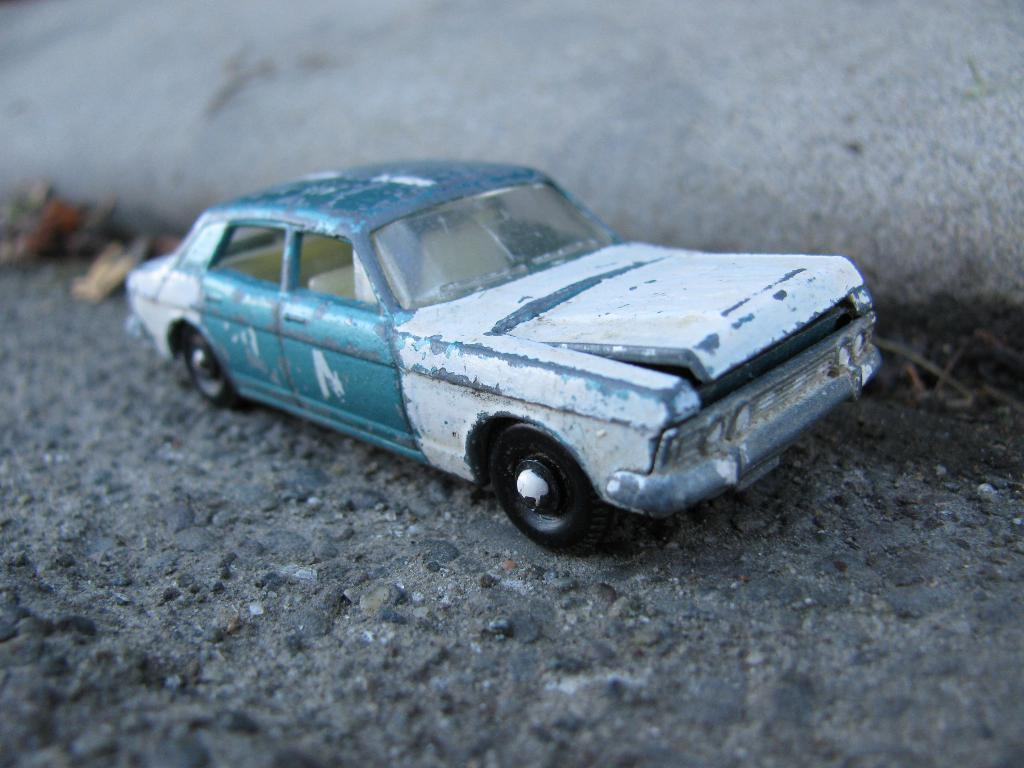What is the main subject of the image? The main subject of the image is a car. What specific features can be observed about the car? The car has wheels. How are the wheels of the car positioned in the image? The wheels of the car are on the ground. How many horses are grazing in the field next to the car in the image? There is no field or horses present in the image; it only features a car with wheels on the ground. Can you tell me how many ants are crawling on the car in the image? There is no indication of any ants crawling on the car in the image. 